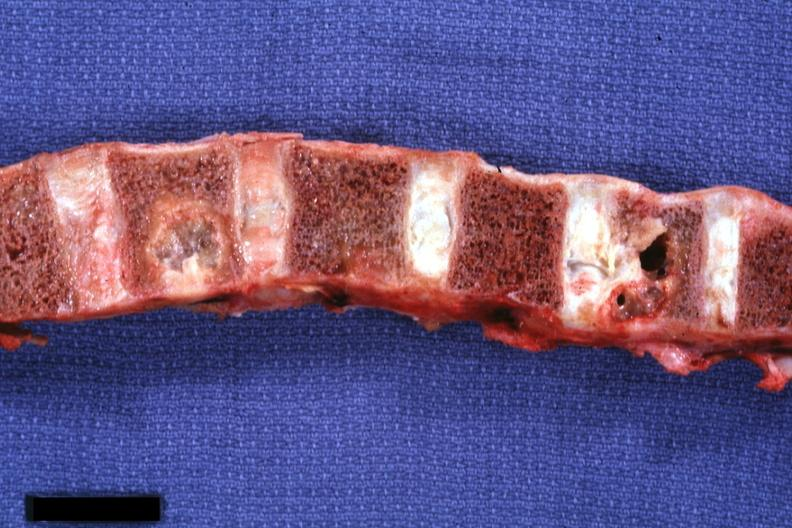how does this image show vertebral column?
Answer the question using a single word or phrase. With well shown gross lesions 